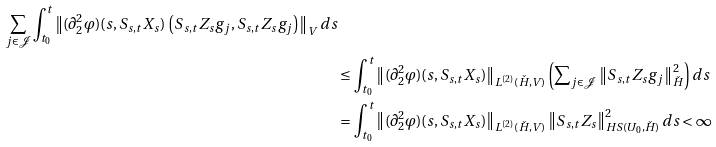<formula> <loc_0><loc_0><loc_500><loc_500>{ \sum _ { j \in \mathcal { J } } \int _ { t _ { 0 } } ^ { t } \left \| ( \partial ^ { 2 } _ { 2 } \varphi ) ( s , S _ { s , t } X _ { s } ) \, \left ( S _ { s , t } Z _ { s } g _ { j } , S _ { s , t } Z _ { s } g _ { j } \right ) \right \| _ { V } d s } \\ & \leq \int _ { t _ { 0 } } ^ { t } \left \| ( \partial ^ { 2 } _ { 2 } \varphi ) ( s , S _ { s , t } X _ { s } ) \right \| _ { L ^ { ( 2 ) } ( \check { H } , V ) } \left ( \sum \nolimits _ { j \in \mathcal { J } } \left \| S _ { s , t } Z _ { s } g _ { j } \right \| _ { \check { H } } ^ { 2 } \right ) d s \\ & = \int _ { t _ { 0 } } ^ { t } \left \| ( \partial ^ { 2 } _ { 2 } \varphi ) ( s , S _ { s , t } X _ { s } ) \right \| _ { L ^ { ( 2 ) } ( \check { H } , V ) } \left \| S _ { s , t } Z _ { s } \right \| _ { H S ( U _ { 0 } , \check { H } ) } ^ { 2 } d s < \infty</formula> 